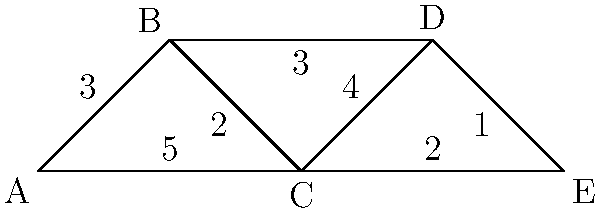On this tactical map, each point represents a location, and the numbers on the lines show how many minutes it takes to travel between locations. If you're at point A and need to evacuate to point E as quickly as possible, what's the fastest route and how long will it take? Let's break this down step-by-step:

1. We need to find the shortest path from A to E.
2. There are several possible routes:
   - A → B → C → D → E
   - A → B → D → E
   - A → C → D → E
   - A → C → E
3. Let's calculate the time for each route:
   - A → B → C → D → E: 3 + 2 + 4 + 1 = 10 minutes
   - A → B → D → E: 3 + 3 + 1 = 7 minutes
   - A → C → D → E: 5 + 4 + 1 = 10 minutes
   - A → C → E: 5 + 2 = 7 minutes
4. We can see that there are two routes that take 7 minutes, which is the shortest time:
   - A → B → D → E
   - A → C → E
5. Both of these routes are equally fast, so either can be considered the correct answer.
Answer: A → B → D → E or A → C → E, 7 minutes 